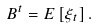<formula> <loc_0><loc_0><loc_500><loc_500>B ^ { t } = E \left [ \xi _ { t } \right ] .</formula> 